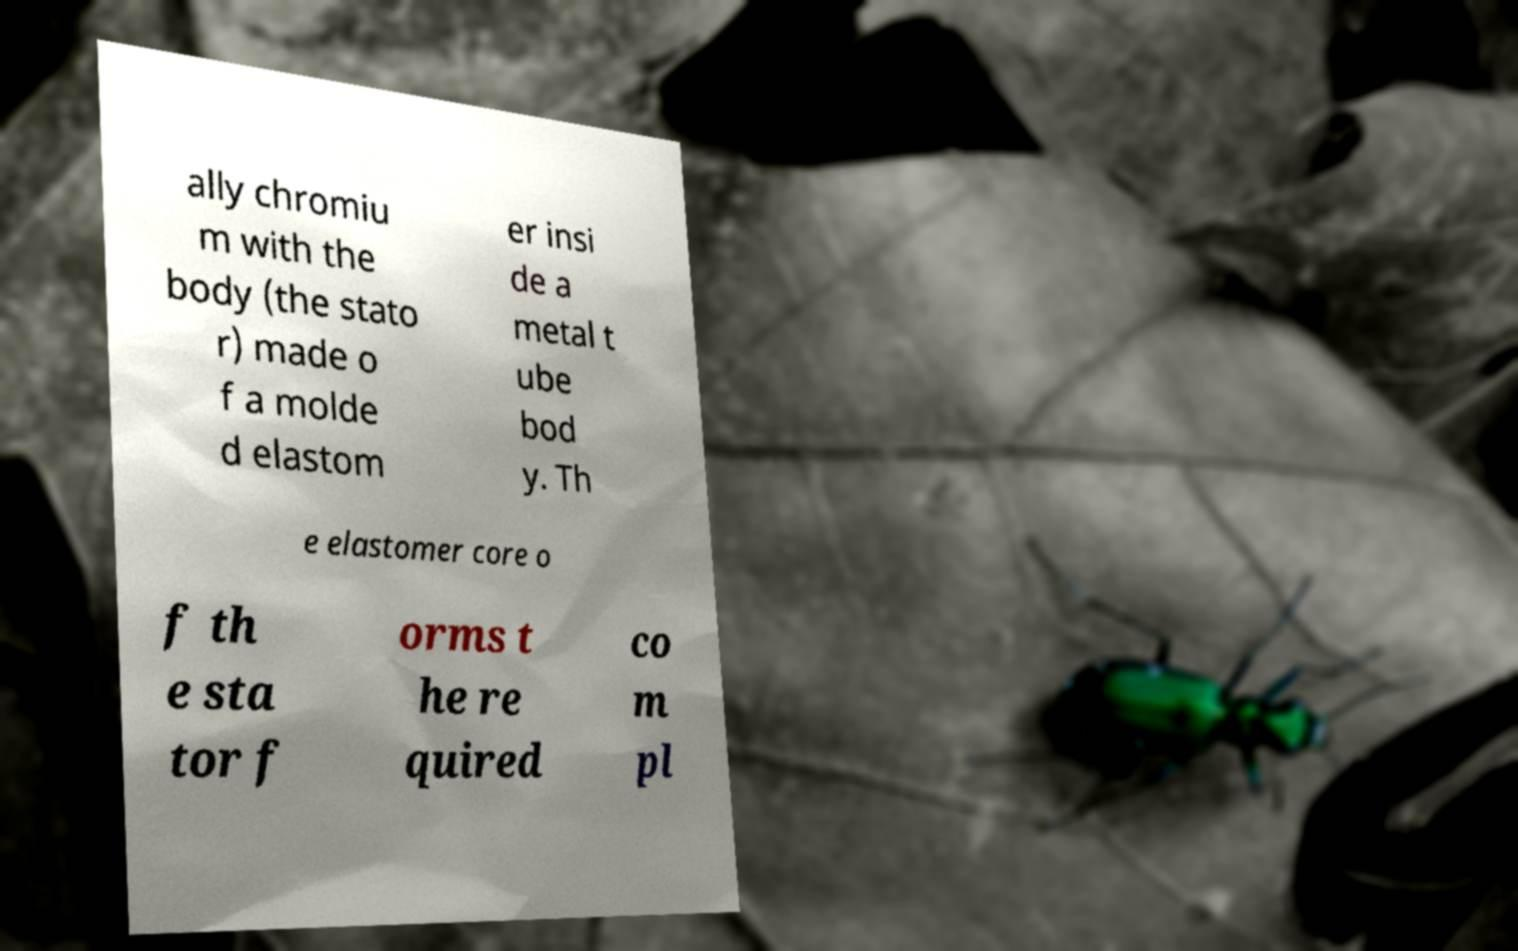Please identify and transcribe the text found in this image. ally chromiu m with the body (the stato r) made o f a molde d elastom er insi de a metal t ube bod y. Th e elastomer core o f th e sta tor f orms t he re quired co m pl 